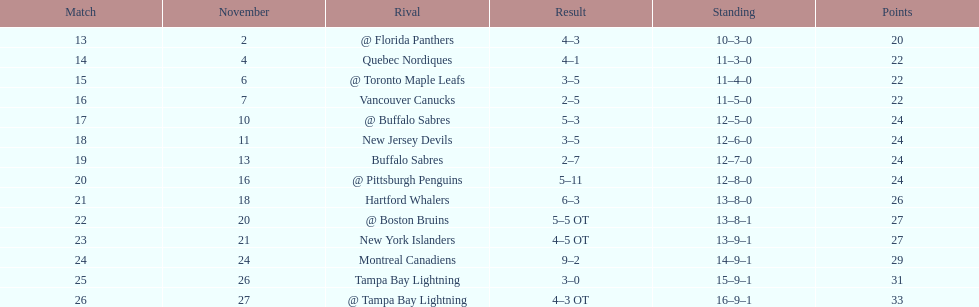What was the number of wins the philadelphia flyers had? 35. 